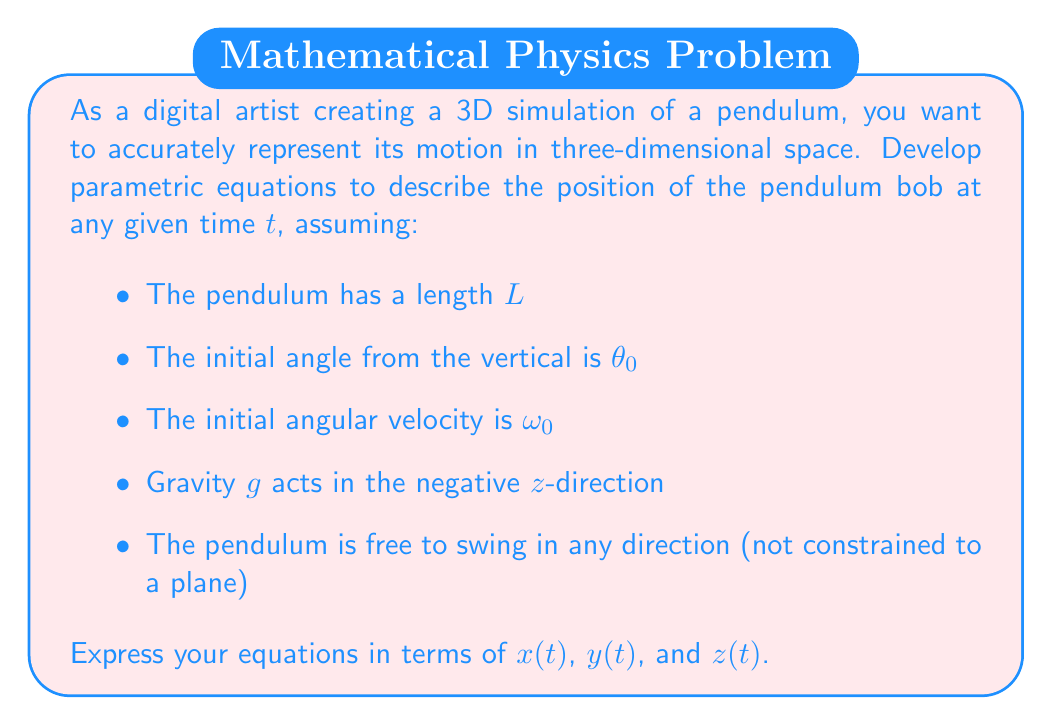Can you solve this math problem? To develop parametric equations for a 3D pendulum, we need to consider its motion in spherical coordinates and then convert to Cartesian coordinates. Let's approach this step-by-step:

1) In spherical coordinates, we have:
   - $r = L$ (constant length)
   - $\theta(t)$ (angle from vertical)
   - $\phi(t)$ (azimuthal angle in xy-plane)

2) For small oscillations, we can approximate $\theta(t)$ as:
   $$\theta(t) = \theta_0 \cos(\omega t + \delta)$$
   where $\omega = \sqrt{\frac{g}{L}}$ is the angular frequency and $\delta$ is a phase constant.

3) The azimuthal angle $\phi(t)$ can be approximated as:
   $$\phi(t) = \phi_0 + \omega_0 t$$
   assuming constant angular velocity in the xy-plane.

4) Now, we can convert from spherical to Cartesian coordinates:
   $$x = L \sin\theta \cos\phi$$
   $$y = L \sin\theta \sin\phi$$
   $$z = -L \cos\theta$$

5) Substituting our expressions for $\theta(t)$ and $\phi(t)$:
   $$x(t) = L \sin(\theta_0 \cos(\omega t + \delta)) \cos(\phi_0 + \omega_0 t)$$
   $$y(t) = L \sin(\theta_0 \cos(\omega t + \delta)) \sin(\phi_0 + \omega_0 t)$$
   $$z(t) = -L \cos(\theta_0 \cos(\omega t + \delta))$$

These equations represent the 3D motion of the pendulum bob over time.
Answer: The parametric equations for the 3D pendulum motion are:

$$x(t) = L \sin(\theta_0 \cos(\omega t + \delta)) \cos(\phi_0 + \omega_0 t)$$
$$y(t) = L \sin(\theta_0 \cos(\omega t + \delta)) \sin(\phi_0 + \omega_0 t)$$
$$z(t) = -L \cos(\theta_0 \cos(\omega t + \delta))$$

Where $L$ is the pendulum length, $\theta_0$ is the initial angle from vertical, $\omega = \sqrt{\frac{g}{L}}$, $\delta$ is a phase constant, $\phi_0$ is the initial azimuthal angle, and $\omega_0$ is the initial angular velocity in the xy-plane. 